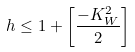<formula> <loc_0><loc_0><loc_500><loc_500>h \leq 1 + \left [ \frac { - K _ { W } ^ { 2 } } { 2 } \right ]</formula> 